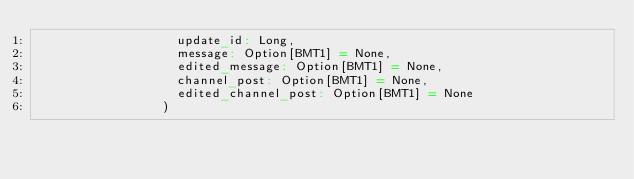<code> <loc_0><loc_0><loc_500><loc_500><_Scala_>                   update_id: Long,
                   message: Option[BMT1] = None,
                   edited_message: Option[BMT1] = None,
                   channel_post: Option[BMT1] = None,
                   edited_channel_post: Option[BMT1] = None
                 )
</code> 